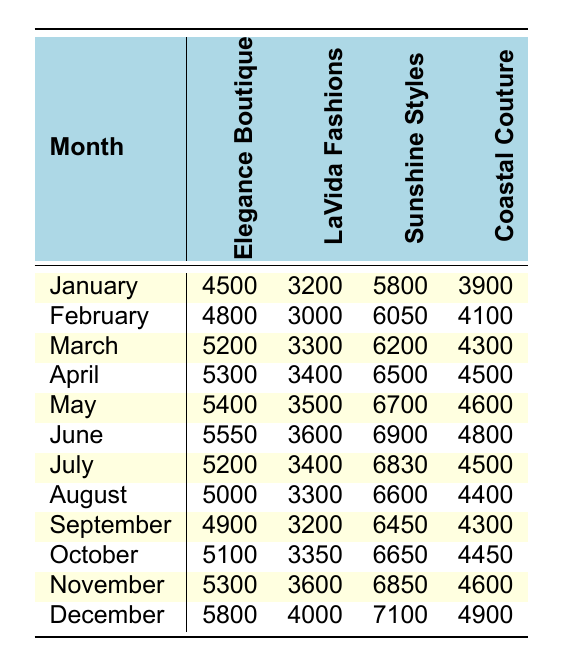What was the highest sales month for Sunshine Styles? By scanning the Sunshine Styles column, I look for the maximum value. The highest sales figure is in December with 7100.
Answer: 7100 In which month did Coastal Couture have the lowest sales? Reviewing the Coastal Couture column, the lowest sales figure is found in January with a total of 3900.
Answer: January What is the total sales for Elegance Boutique across all months? Adding together all the monthly sales values for Elegance Boutique: 4500 + 4800 + 5200 + 5300 + 5400 + 5550 + 5200 + 5000 + 4900 + 5100 + 5300 + 5800 = 60600.
Answer: 60600 Did LaVida Fashions ever exceed 4000 in sales? Looking through the LaVida Fashions column for any monthly sales figures above 4000. The highest sales recorded is 4000 in December, indicating it did exceed 4000.
Answer: Yes What was the average monthly sales for Coastal Couture? To find the average, add all the sales from Coastal Couture: 3900 + 4100 + 4500 + 4600 + 4800 + 4500 + 4400 + 4300 + 4450 + 4600 + 4900 = 48250. Divide by 12 months, which gives an average of 4020.83 when rounded to two decimal places.
Answer: 4020.83 Which boutique consistently had sales under 4000, if any? Reviewing the monthly sales of each boutique, Coastal Couture is the only one that had continuous sales figures under 4000 in the month of January.
Answer: Yes What was the difference in sales between Sunshine Styles and Elegance Boutique in April? In April, Sunshine Styles had sales of 6500 while Elegance Boutique had 5300. The difference is 6500 - 5300 = 1200.
Answer: 1200 Which boutique had the most consistent growth throughout the year? By analyzing the monthly trends, Elegance Boutique showed steady increases most months, only dropping slightly in July. Therefore, it is deemed the most consistently growing.
Answer: Elegance Boutique 